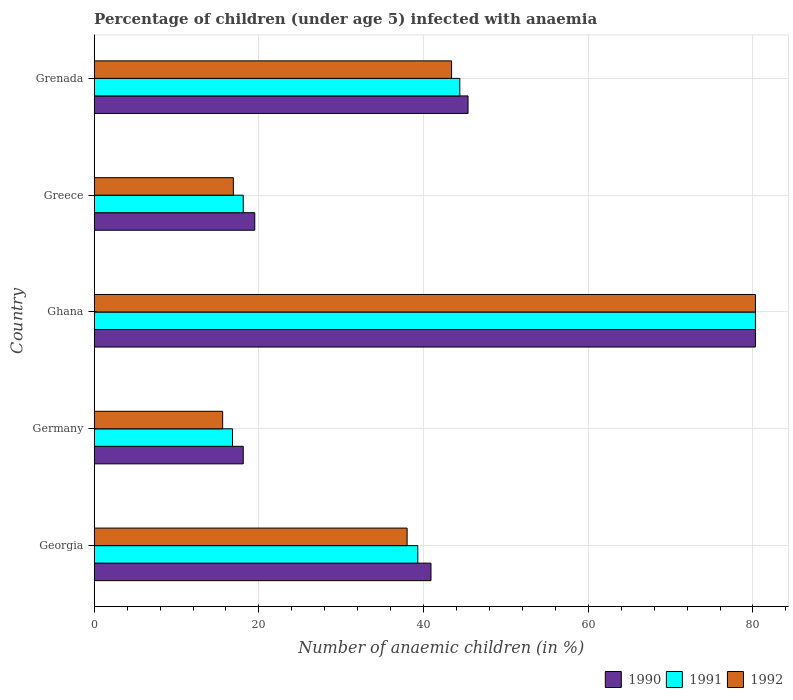How many different coloured bars are there?
Offer a very short reply. 3. Are the number of bars per tick equal to the number of legend labels?
Ensure brevity in your answer.  Yes. How many bars are there on the 3rd tick from the bottom?
Make the answer very short. 3. What is the percentage of children infected with anaemia in in 1991 in Ghana?
Your answer should be very brief. 80.3. Across all countries, what is the maximum percentage of children infected with anaemia in in 1990?
Make the answer very short. 80.3. In which country was the percentage of children infected with anaemia in in 1992 maximum?
Ensure brevity in your answer.  Ghana. What is the total percentage of children infected with anaemia in in 1992 in the graph?
Provide a succinct answer. 194.2. What is the difference between the percentage of children infected with anaemia in in 1990 in Greece and that in Grenada?
Keep it short and to the point. -25.9. What is the difference between the percentage of children infected with anaemia in in 1991 in Ghana and the percentage of children infected with anaemia in in 1992 in Georgia?
Your answer should be very brief. 42.3. What is the average percentage of children infected with anaemia in in 1991 per country?
Offer a very short reply. 39.78. What is the difference between the percentage of children infected with anaemia in in 1991 and percentage of children infected with anaemia in in 1992 in Greece?
Your answer should be very brief. 1.2. What is the ratio of the percentage of children infected with anaemia in in 1990 in Georgia to that in Grenada?
Offer a terse response. 0.9. Is the percentage of children infected with anaemia in in 1992 in Georgia less than that in Germany?
Your response must be concise. No. Is the difference between the percentage of children infected with anaemia in in 1991 in Germany and Ghana greater than the difference between the percentage of children infected with anaemia in in 1992 in Germany and Ghana?
Ensure brevity in your answer.  Yes. What is the difference between the highest and the second highest percentage of children infected with anaemia in in 1992?
Your response must be concise. 36.9. What is the difference between the highest and the lowest percentage of children infected with anaemia in in 1992?
Make the answer very short. 64.7. Is the sum of the percentage of children infected with anaemia in in 1990 in Greece and Grenada greater than the maximum percentage of children infected with anaemia in in 1991 across all countries?
Give a very brief answer. No. What does the 3rd bar from the top in Ghana represents?
Your answer should be compact. 1990. How many bars are there?
Offer a terse response. 15. How many countries are there in the graph?
Offer a terse response. 5. What is the difference between two consecutive major ticks on the X-axis?
Offer a very short reply. 20. Are the values on the major ticks of X-axis written in scientific E-notation?
Offer a terse response. No. Does the graph contain any zero values?
Make the answer very short. No. Does the graph contain grids?
Your answer should be very brief. Yes. Where does the legend appear in the graph?
Keep it short and to the point. Bottom right. How are the legend labels stacked?
Provide a short and direct response. Horizontal. What is the title of the graph?
Your answer should be compact. Percentage of children (under age 5) infected with anaemia. What is the label or title of the X-axis?
Make the answer very short. Number of anaemic children (in %). What is the label or title of the Y-axis?
Keep it short and to the point. Country. What is the Number of anaemic children (in %) in 1990 in Georgia?
Make the answer very short. 40.9. What is the Number of anaemic children (in %) in 1991 in Georgia?
Ensure brevity in your answer.  39.3. What is the Number of anaemic children (in %) in 1992 in Germany?
Give a very brief answer. 15.6. What is the Number of anaemic children (in %) of 1990 in Ghana?
Give a very brief answer. 80.3. What is the Number of anaemic children (in %) in 1991 in Ghana?
Your answer should be compact. 80.3. What is the Number of anaemic children (in %) of 1992 in Ghana?
Offer a very short reply. 80.3. What is the Number of anaemic children (in %) of 1992 in Greece?
Provide a succinct answer. 16.9. What is the Number of anaemic children (in %) of 1990 in Grenada?
Provide a short and direct response. 45.4. What is the Number of anaemic children (in %) in 1991 in Grenada?
Your answer should be very brief. 44.4. What is the Number of anaemic children (in %) of 1992 in Grenada?
Provide a short and direct response. 43.4. Across all countries, what is the maximum Number of anaemic children (in %) of 1990?
Your response must be concise. 80.3. Across all countries, what is the maximum Number of anaemic children (in %) of 1991?
Provide a short and direct response. 80.3. Across all countries, what is the maximum Number of anaemic children (in %) of 1992?
Make the answer very short. 80.3. Across all countries, what is the minimum Number of anaemic children (in %) in 1990?
Give a very brief answer. 18.1. What is the total Number of anaemic children (in %) in 1990 in the graph?
Provide a succinct answer. 204.2. What is the total Number of anaemic children (in %) in 1991 in the graph?
Make the answer very short. 198.9. What is the total Number of anaemic children (in %) in 1992 in the graph?
Your answer should be very brief. 194.2. What is the difference between the Number of anaemic children (in %) of 1990 in Georgia and that in Germany?
Keep it short and to the point. 22.8. What is the difference between the Number of anaemic children (in %) of 1991 in Georgia and that in Germany?
Ensure brevity in your answer.  22.5. What is the difference between the Number of anaemic children (in %) of 1992 in Georgia and that in Germany?
Your response must be concise. 22.4. What is the difference between the Number of anaemic children (in %) in 1990 in Georgia and that in Ghana?
Provide a short and direct response. -39.4. What is the difference between the Number of anaemic children (in %) in 1991 in Georgia and that in Ghana?
Provide a succinct answer. -41. What is the difference between the Number of anaemic children (in %) in 1992 in Georgia and that in Ghana?
Provide a succinct answer. -42.3. What is the difference between the Number of anaemic children (in %) of 1990 in Georgia and that in Greece?
Your response must be concise. 21.4. What is the difference between the Number of anaemic children (in %) in 1991 in Georgia and that in Greece?
Keep it short and to the point. 21.2. What is the difference between the Number of anaemic children (in %) of 1992 in Georgia and that in Greece?
Provide a succinct answer. 21.1. What is the difference between the Number of anaemic children (in %) of 1991 in Georgia and that in Grenada?
Give a very brief answer. -5.1. What is the difference between the Number of anaemic children (in %) in 1990 in Germany and that in Ghana?
Your answer should be very brief. -62.2. What is the difference between the Number of anaemic children (in %) in 1991 in Germany and that in Ghana?
Keep it short and to the point. -63.5. What is the difference between the Number of anaemic children (in %) of 1992 in Germany and that in Ghana?
Give a very brief answer. -64.7. What is the difference between the Number of anaemic children (in %) in 1992 in Germany and that in Greece?
Offer a terse response. -1.3. What is the difference between the Number of anaemic children (in %) of 1990 in Germany and that in Grenada?
Your answer should be very brief. -27.3. What is the difference between the Number of anaemic children (in %) of 1991 in Germany and that in Grenada?
Your answer should be very brief. -27.6. What is the difference between the Number of anaemic children (in %) of 1992 in Germany and that in Grenada?
Ensure brevity in your answer.  -27.8. What is the difference between the Number of anaemic children (in %) of 1990 in Ghana and that in Greece?
Your response must be concise. 60.8. What is the difference between the Number of anaemic children (in %) of 1991 in Ghana and that in Greece?
Your answer should be compact. 62.2. What is the difference between the Number of anaemic children (in %) in 1992 in Ghana and that in Greece?
Offer a very short reply. 63.4. What is the difference between the Number of anaemic children (in %) in 1990 in Ghana and that in Grenada?
Your answer should be compact. 34.9. What is the difference between the Number of anaemic children (in %) of 1991 in Ghana and that in Grenada?
Provide a succinct answer. 35.9. What is the difference between the Number of anaemic children (in %) in 1992 in Ghana and that in Grenada?
Your answer should be compact. 36.9. What is the difference between the Number of anaemic children (in %) of 1990 in Greece and that in Grenada?
Provide a short and direct response. -25.9. What is the difference between the Number of anaemic children (in %) of 1991 in Greece and that in Grenada?
Your answer should be very brief. -26.3. What is the difference between the Number of anaemic children (in %) in 1992 in Greece and that in Grenada?
Give a very brief answer. -26.5. What is the difference between the Number of anaemic children (in %) of 1990 in Georgia and the Number of anaemic children (in %) of 1991 in Germany?
Give a very brief answer. 24.1. What is the difference between the Number of anaemic children (in %) in 1990 in Georgia and the Number of anaemic children (in %) in 1992 in Germany?
Provide a succinct answer. 25.3. What is the difference between the Number of anaemic children (in %) in 1991 in Georgia and the Number of anaemic children (in %) in 1992 in Germany?
Provide a short and direct response. 23.7. What is the difference between the Number of anaemic children (in %) of 1990 in Georgia and the Number of anaemic children (in %) of 1991 in Ghana?
Keep it short and to the point. -39.4. What is the difference between the Number of anaemic children (in %) of 1990 in Georgia and the Number of anaemic children (in %) of 1992 in Ghana?
Offer a very short reply. -39.4. What is the difference between the Number of anaemic children (in %) in 1991 in Georgia and the Number of anaemic children (in %) in 1992 in Ghana?
Offer a terse response. -41. What is the difference between the Number of anaemic children (in %) of 1990 in Georgia and the Number of anaemic children (in %) of 1991 in Greece?
Give a very brief answer. 22.8. What is the difference between the Number of anaemic children (in %) in 1991 in Georgia and the Number of anaemic children (in %) in 1992 in Greece?
Offer a very short reply. 22.4. What is the difference between the Number of anaemic children (in %) in 1990 in Georgia and the Number of anaemic children (in %) in 1992 in Grenada?
Your response must be concise. -2.5. What is the difference between the Number of anaemic children (in %) in 1991 in Georgia and the Number of anaemic children (in %) in 1992 in Grenada?
Ensure brevity in your answer.  -4.1. What is the difference between the Number of anaemic children (in %) of 1990 in Germany and the Number of anaemic children (in %) of 1991 in Ghana?
Keep it short and to the point. -62.2. What is the difference between the Number of anaemic children (in %) of 1990 in Germany and the Number of anaemic children (in %) of 1992 in Ghana?
Give a very brief answer. -62.2. What is the difference between the Number of anaemic children (in %) in 1991 in Germany and the Number of anaemic children (in %) in 1992 in Ghana?
Your answer should be compact. -63.5. What is the difference between the Number of anaemic children (in %) in 1990 in Germany and the Number of anaemic children (in %) in 1992 in Greece?
Your answer should be very brief. 1.2. What is the difference between the Number of anaemic children (in %) of 1990 in Germany and the Number of anaemic children (in %) of 1991 in Grenada?
Make the answer very short. -26.3. What is the difference between the Number of anaemic children (in %) of 1990 in Germany and the Number of anaemic children (in %) of 1992 in Grenada?
Provide a short and direct response. -25.3. What is the difference between the Number of anaemic children (in %) in 1991 in Germany and the Number of anaemic children (in %) in 1992 in Grenada?
Ensure brevity in your answer.  -26.6. What is the difference between the Number of anaemic children (in %) of 1990 in Ghana and the Number of anaemic children (in %) of 1991 in Greece?
Ensure brevity in your answer.  62.2. What is the difference between the Number of anaemic children (in %) of 1990 in Ghana and the Number of anaemic children (in %) of 1992 in Greece?
Give a very brief answer. 63.4. What is the difference between the Number of anaemic children (in %) in 1991 in Ghana and the Number of anaemic children (in %) in 1992 in Greece?
Your answer should be compact. 63.4. What is the difference between the Number of anaemic children (in %) of 1990 in Ghana and the Number of anaemic children (in %) of 1991 in Grenada?
Offer a terse response. 35.9. What is the difference between the Number of anaemic children (in %) in 1990 in Ghana and the Number of anaemic children (in %) in 1992 in Grenada?
Your answer should be compact. 36.9. What is the difference between the Number of anaemic children (in %) of 1991 in Ghana and the Number of anaemic children (in %) of 1992 in Grenada?
Give a very brief answer. 36.9. What is the difference between the Number of anaemic children (in %) of 1990 in Greece and the Number of anaemic children (in %) of 1991 in Grenada?
Give a very brief answer. -24.9. What is the difference between the Number of anaemic children (in %) in 1990 in Greece and the Number of anaemic children (in %) in 1992 in Grenada?
Provide a succinct answer. -23.9. What is the difference between the Number of anaemic children (in %) in 1991 in Greece and the Number of anaemic children (in %) in 1992 in Grenada?
Provide a short and direct response. -25.3. What is the average Number of anaemic children (in %) in 1990 per country?
Provide a short and direct response. 40.84. What is the average Number of anaemic children (in %) of 1991 per country?
Provide a short and direct response. 39.78. What is the average Number of anaemic children (in %) of 1992 per country?
Make the answer very short. 38.84. What is the difference between the Number of anaemic children (in %) in 1991 and Number of anaemic children (in %) in 1992 in Georgia?
Offer a very short reply. 1.3. What is the difference between the Number of anaemic children (in %) of 1990 and Number of anaemic children (in %) of 1992 in Germany?
Offer a terse response. 2.5. What is the difference between the Number of anaemic children (in %) in 1991 and Number of anaemic children (in %) in 1992 in Ghana?
Your response must be concise. 0. What is the difference between the Number of anaemic children (in %) in 1990 and Number of anaemic children (in %) in 1992 in Greece?
Your response must be concise. 2.6. What is the difference between the Number of anaemic children (in %) of 1990 and Number of anaemic children (in %) of 1991 in Grenada?
Your answer should be compact. 1. What is the ratio of the Number of anaemic children (in %) in 1990 in Georgia to that in Germany?
Offer a very short reply. 2.26. What is the ratio of the Number of anaemic children (in %) in 1991 in Georgia to that in Germany?
Offer a terse response. 2.34. What is the ratio of the Number of anaemic children (in %) in 1992 in Georgia to that in Germany?
Provide a short and direct response. 2.44. What is the ratio of the Number of anaemic children (in %) of 1990 in Georgia to that in Ghana?
Offer a terse response. 0.51. What is the ratio of the Number of anaemic children (in %) of 1991 in Georgia to that in Ghana?
Your answer should be compact. 0.49. What is the ratio of the Number of anaemic children (in %) in 1992 in Georgia to that in Ghana?
Your response must be concise. 0.47. What is the ratio of the Number of anaemic children (in %) of 1990 in Georgia to that in Greece?
Your response must be concise. 2.1. What is the ratio of the Number of anaemic children (in %) of 1991 in Georgia to that in Greece?
Your response must be concise. 2.17. What is the ratio of the Number of anaemic children (in %) in 1992 in Georgia to that in Greece?
Offer a terse response. 2.25. What is the ratio of the Number of anaemic children (in %) of 1990 in Georgia to that in Grenada?
Offer a very short reply. 0.9. What is the ratio of the Number of anaemic children (in %) of 1991 in Georgia to that in Grenada?
Your answer should be very brief. 0.89. What is the ratio of the Number of anaemic children (in %) in 1992 in Georgia to that in Grenada?
Keep it short and to the point. 0.88. What is the ratio of the Number of anaemic children (in %) of 1990 in Germany to that in Ghana?
Your answer should be compact. 0.23. What is the ratio of the Number of anaemic children (in %) in 1991 in Germany to that in Ghana?
Provide a succinct answer. 0.21. What is the ratio of the Number of anaemic children (in %) of 1992 in Germany to that in Ghana?
Give a very brief answer. 0.19. What is the ratio of the Number of anaemic children (in %) of 1990 in Germany to that in Greece?
Provide a short and direct response. 0.93. What is the ratio of the Number of anaemic children (in %) of 1991 in Germany to that in Greece?
Keep it short and to the point. 0.93. What is the ratio of the Number of anaemic children (in %) of 1992 in Germany to that in Greece?
Offer a very short reply. 0.92. What is the ratio of the Number of anaemic children (in %) of 1990 in Germany to that in Grenada?
Your response must be concise. 0.4. What is the ratio of the Number of anaemic children (in %) of 1991 in Germany to that in Grenada?
Offer a terse response. 0.38. What is the ratio of the Number of anaemic children (in %) in 1992 in Germany to that in Grenada?
Make the answer very short. 0.36. What is the ratio of the Number of anaemic children (in %) in 1990 in Ghana to that in Greece?
Your answer should be very brief. 4.12. What is the ratio of the Number of anaemic children (in %) of 1991 in Ghana to that in Greece?
Your response must be concise. 4.44. What is the ratio of the Number of anaemic children (in %) in 1992 in Ghana to that in Greece?
Make the answer very short. 4.75. What is the ratio of the Number of anaemic children (in %) in 1990 in Ghana to that in Grenada?
Provide a short and direct response. 1.77. What is the ratio of the Number of anaemic children (in %) of 1991 in Ghana to that in Grenada?
Keep it short and to the point. 1.81. What is the ratio of the Number of anaemic children (in %) of 1992 in Ghana to that in Grenada?
Ensure brevity in your answer.  1.85. What is the ratio of the Number of anaemic children (in %) in 1990 in Greece to that in Grenada?
Your answer should be compact. 0.43. What is the ratio of the Number of anaemic children (in %) in 1991 in Greece to that in Grenada?
Your response must be concise. 0.41. What is the ratio of the Number of anaemic children (in %) in 1992 in Greece to that in Grenada?
Your answer should be compact. 0.39. What is the difference between the highest and the second highest Number of anaemic children (in %) in 1990?
Provide a succinct answer. 34.9. What is the difference between the highest and the second highest Number of anaemic children (in %) of 1991?
Offer a very short reply. 35.9. What is the difference between the highest and the second highest Number of anaemic children (in %) of 1992?
Offer a very short reply. 36.9. What is the difference between the highest and the lowest Number of anaemic children (in %) of 1990?
Your answer should be very brief. 62.2. What is the difference between the highest and the lowest Number of anaemic children (in %) of 1991?
Provide a short and direct response. 63.5. What is the difference between the highest and the lowest Number of anaemic children (in %) in 1992?
Ensure brevity in your answer.  64.7. 